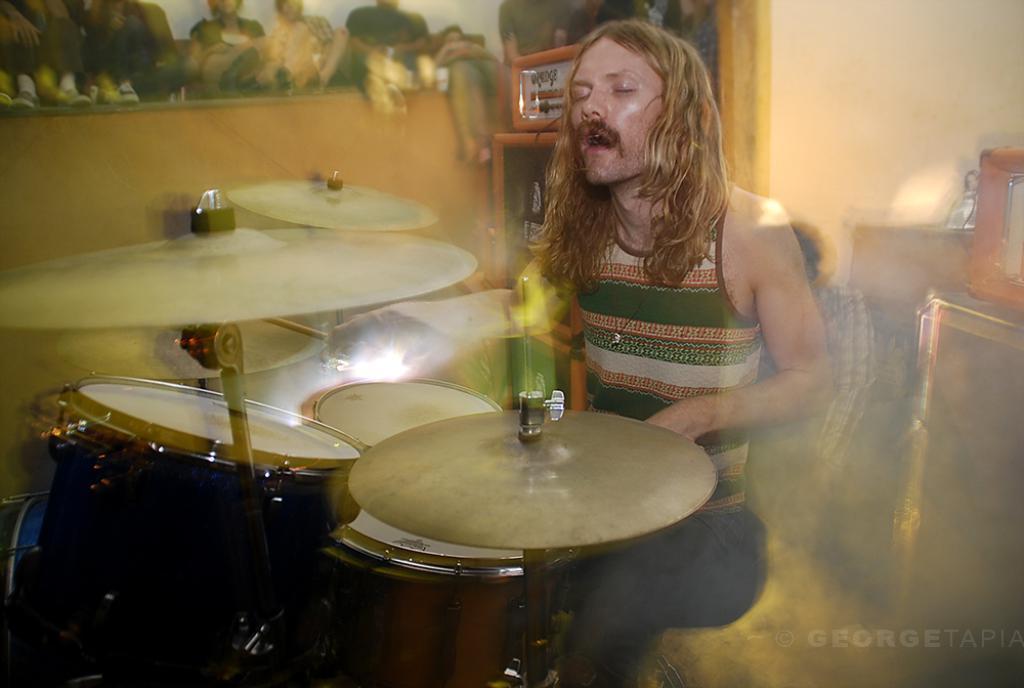Could you give a brief overview of what you see in this image? As we can see in the image there is a man playing musical drums. 